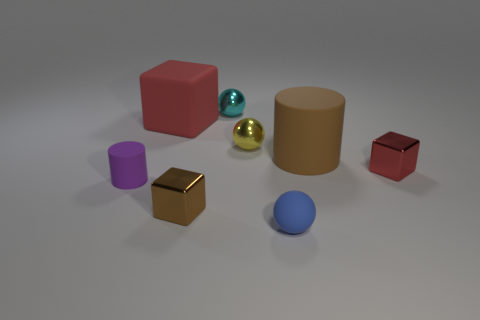Subtract all yellow balls. How many red blocks are left? 2 Subtract all yellow balls. How many balls are left? 2 Add 1 big brown shiny cubes. How many objects exist? 9 Subtract all cubes. How many objects are left? 5 Subtract 0 cyan blocks. How many objects are left? 8 Subtract all small metallic cubes. Subtract all large cubes. How many objects are left? 5 Add 4 tiny blue rubber things. How many tiny blue rubber things are left? 5 Add 7 large red metal cubes. How many large red metal cubes exist? 7 